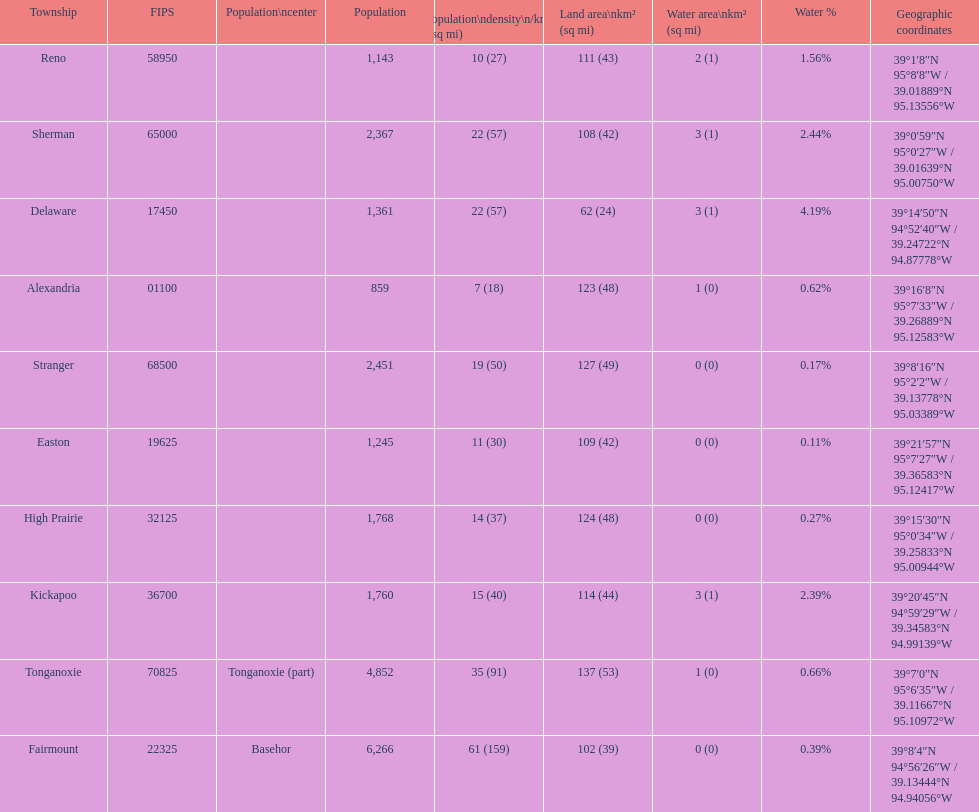What township has the largest population? Fairmount. 